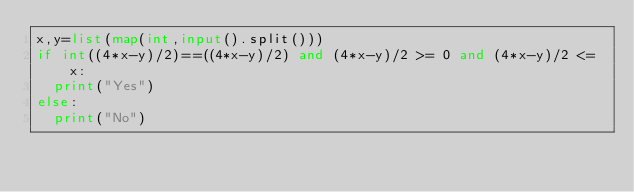<code> <loc_0><loc_0><loc_500><loc_500><_Python_>x,y=list(map(int,input().split()))
if int((4*x-y)/2)==((4*x-y)/2) and (4*x-y)/2 >= 0 and (4*x-y)/2 <= x:
  print("Yes")
else:
  print("No")</code> 